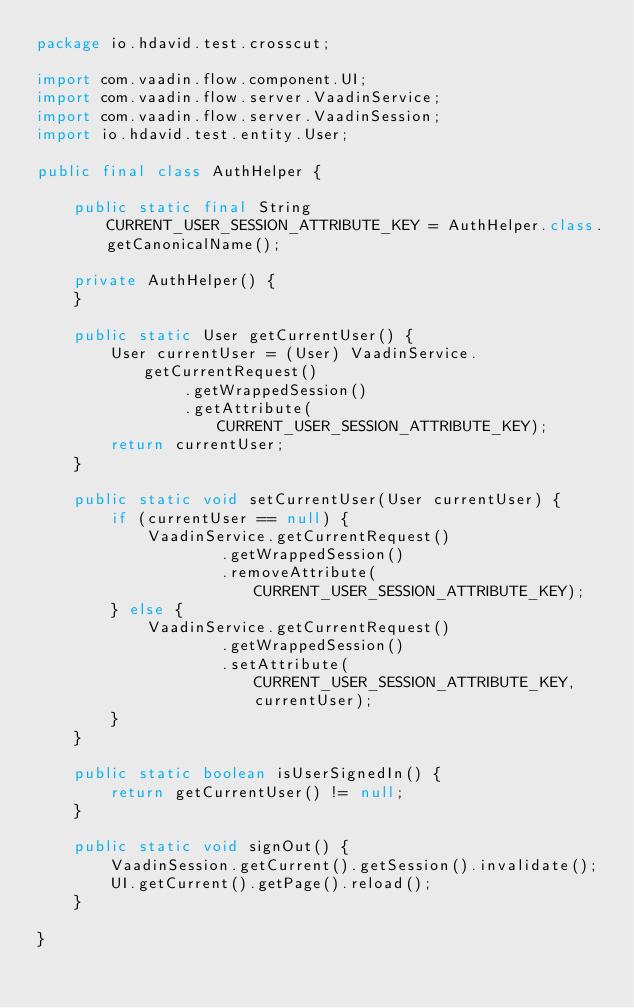Convert code to text. <code><loc_0><loc_0><loc_500><loc_500><_Java_>package io.hdavid.test.crosscut;

import com.vaadin.flow.component.UI;
import com.vaadin.flow.server.VaadinService;
import com.vaadin.flow.server.VaadinSession;
import io.hdavid.test.entity.User;

public final class AuthHelper {

    public static final String CURRENT_USER_SESSION_ATTRIBUTE_KEY = AuthHelper.class.getCanonicalName();

    private AuthHelper() {
    }

    public static User getCurrentUser() {
        User currentUser = (User) VaadinService.getCurrentRequest()
                .getWrappedSession()
                .getAttribute(CURRENT_USER_SESSION_ATTRIBUTE_KEY);
        return currentUser;
    }

    public static void setCurrentUser(User currentUser) {
        if (currentUser == null) {
            VaadinService.getCurrentRequest()
                    .getWrappedSession()
                    .removeAttribute(CURRENT_USER_SESSION_ATTRIBUTE_KEY);
        } else {
            VaadinService.getCurrentRequest()
                    .getWrappedSession()
                    .setAttribute(CURRENT_USER_SESSION_ATTRIBUTE_KEY, currentUser);
        }
    }

    public static boolean isUserSignedIn() {
        return getCurrentUser() != null;
    }

    public static void signOut() {
        VaadinSession.getCurrent().getSession().invalidate();
        UI.getCurrent().getPage().reload();
    }

}
</code> 